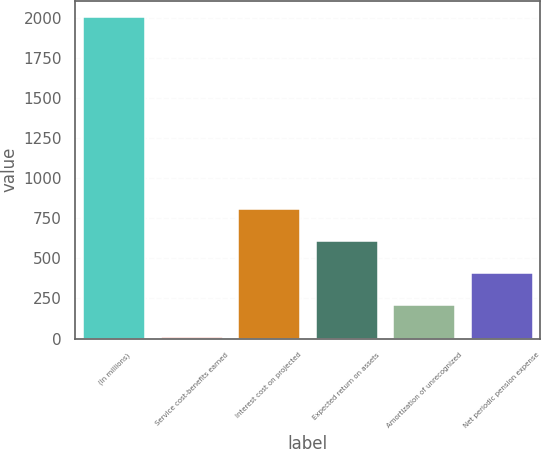Convert chart. <chart><loc_0><loc_0><loc_500><loc_500><bar_chart><fcel>(In millions)<fcel>Service cost-benefits earned<fcel>Interest cost on projected<fcel>Expected return on assets<fcel>Amortization of unrecognized<fcel>Net periodic pension expense<nl><fcel>2004<fcel>7<fcel>805.8<fcel>606.1<fcel>206.7<fcel>406.4<nl></chart> 